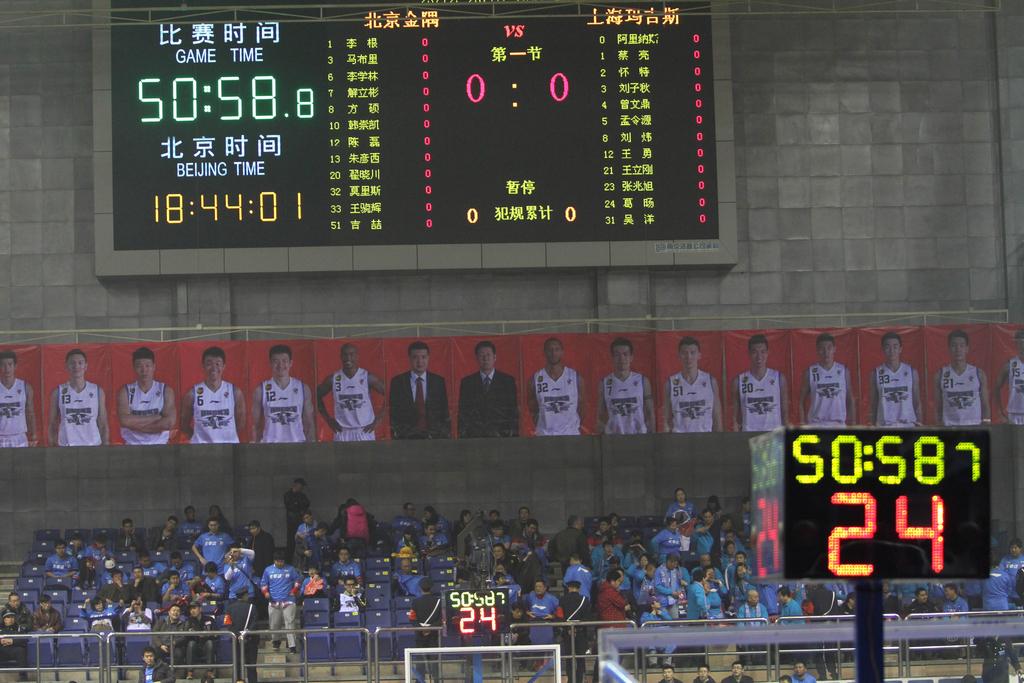What are the two times mentioned on the scoreboard?
Offer a terse response. 50:58.8 and 18:44:01. What is the current score?
Give a very brief answer. 0-0. 